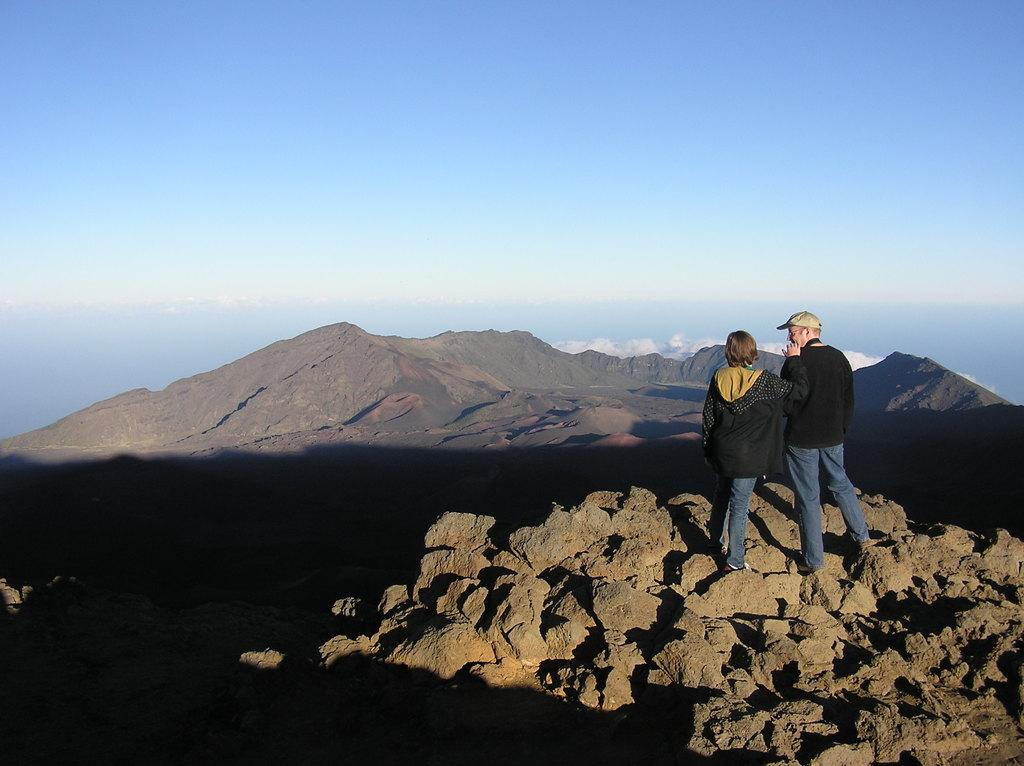What are the two people in the image? There is a man and a woman in the image. Where are the man and woman located in the image? The man and woman are on the right side of the image. What is the setting in which the man and woman are situated? They are on rocks. What type of hat is the man wearing in the image? There is no hat visible on the man in the image. Are there any police officers present in the image? There is no indication of any police officers in the image. 